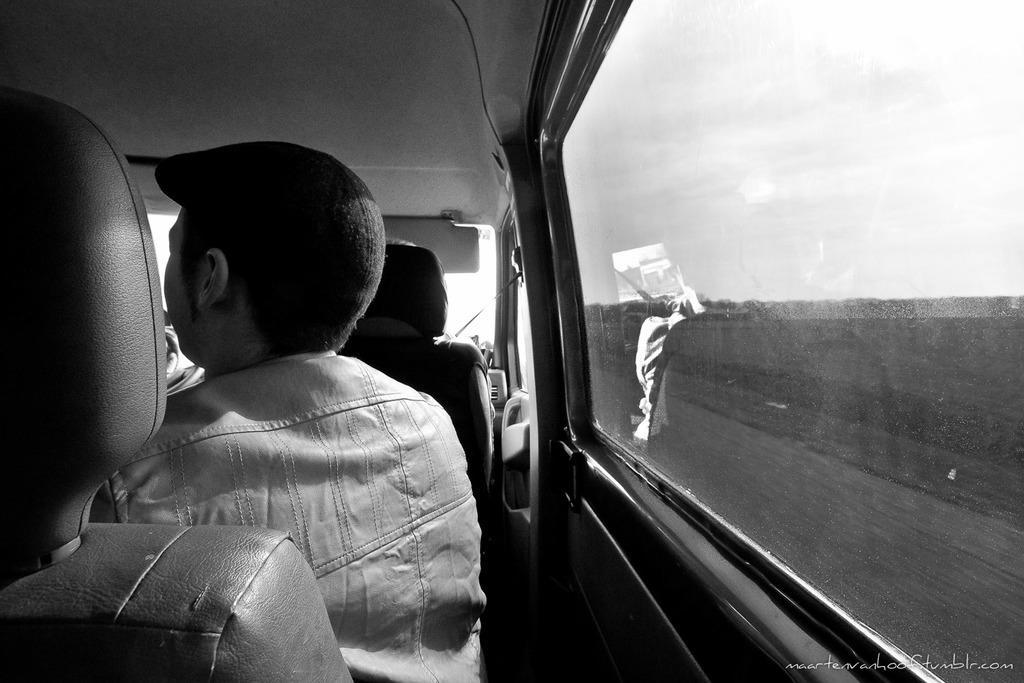How would you summarize this image in a sentence or two? In this picture we can see some persons are sitting in the seats in the vehicle. 